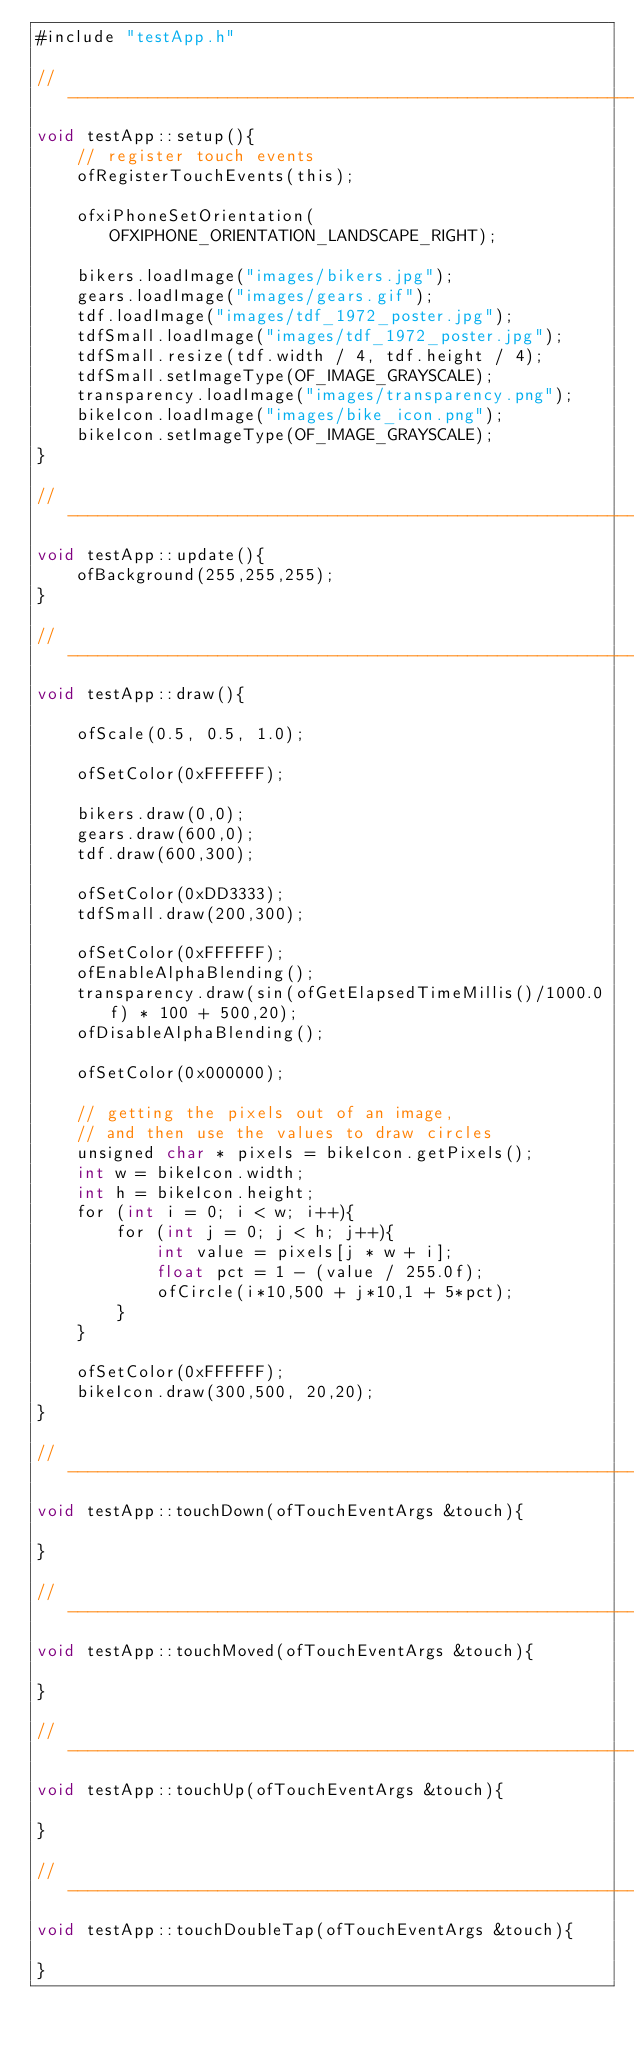Convert code to text. <code><loc_0><loc_0><loc_500><loc_500><_ObjectiveC_>#include "testApp.h"

//--------------------------------------------------------------
void testApp::setup(){	
	// register touch events
	ofRegisterTouchEvents(this);

	ofxiPhoneSetOrientation(OFXIPHONE_ORIENTATION_LANDSCAPE_RIGHT);
	
	bikers.loadImage("images/bikers.jpg");
	gears.loadImage("images/gears.gif");
	tdf.loadImage("images/tdf_1972_poster.jpg");
	tdfSmall.loadImage("images/tdf_1972_poster.jpg");
	tdfSmall.resize(tdf.width / 4, tdf.height / 4);
	tdfSmall.setImageType(OF_IMAGE_GRAYSCALE);
	transparency.loadImage("images/transparency.png");
	bikeIcon.loadImage("images/bike_icon.png");
	bikeIcon.setImageType(OF_IMAGE_GRAYSCALE);
}

//--------------------------------------------------------------
void testApp::update(){
	ofBackground(255,255,255);	
}

//--------------------------------------------------------------
void testApp::draw(){	

	ofScale(0.5, 0.5, 1.0);

	ofSetColor(0xFFFFFF);
	
	bikers.draw(0,0);
	gears.draw(600,0);
	tdf.draw(600,300);
	
	ofSetColor(0xDD3333);
	tdfSmall.draw(200,300);
	
	ofSetColor(0xFFFFFF);
	ofEnableAlphaBlending();
	transparency.draw(sin(ofGetElapsedTimeMillis()/1000.0f) * 100 + 500,20);
	ofDisableAlphaBlending();
	
	ofSetColor(0x000000);
	
	// getting the pixels out of an image, 
	// and then use the values to draw circles
	unsigned char * pixels = bikeIcon.getPixels();
	int w = bikeIcon.width;
	int h = bikeIcon.height;
	for (int i = 0; i < w; i++){
		for (int j = 0; j < h; j++){
			int value = pixels[j * w + i];
			float pct = 1 - (value / 255.0f);
			ofCircle(i*10,500 + j*10,1 + 5*pct);		
		}
	}
	
	ofSetColor(0xFFFFFF);
	bikeIcon.draw(300,500, 20,20);
}

//--------------------------------------------------------------
void testApp::touchDown(ofTouchEventArgs &touch){

}

//--------------------------------------------------------------
void testApp::touchMoved(ofTouchEventArgs &touch){

}

//--------------------------------------------------------------
void testApp::touchUp(ofTouchEventArgs &touch){

}

//--------------------------------------------------------------
void testApp::touchDoubleTap(ofTouchEventArgs &touch){

}
</code> 